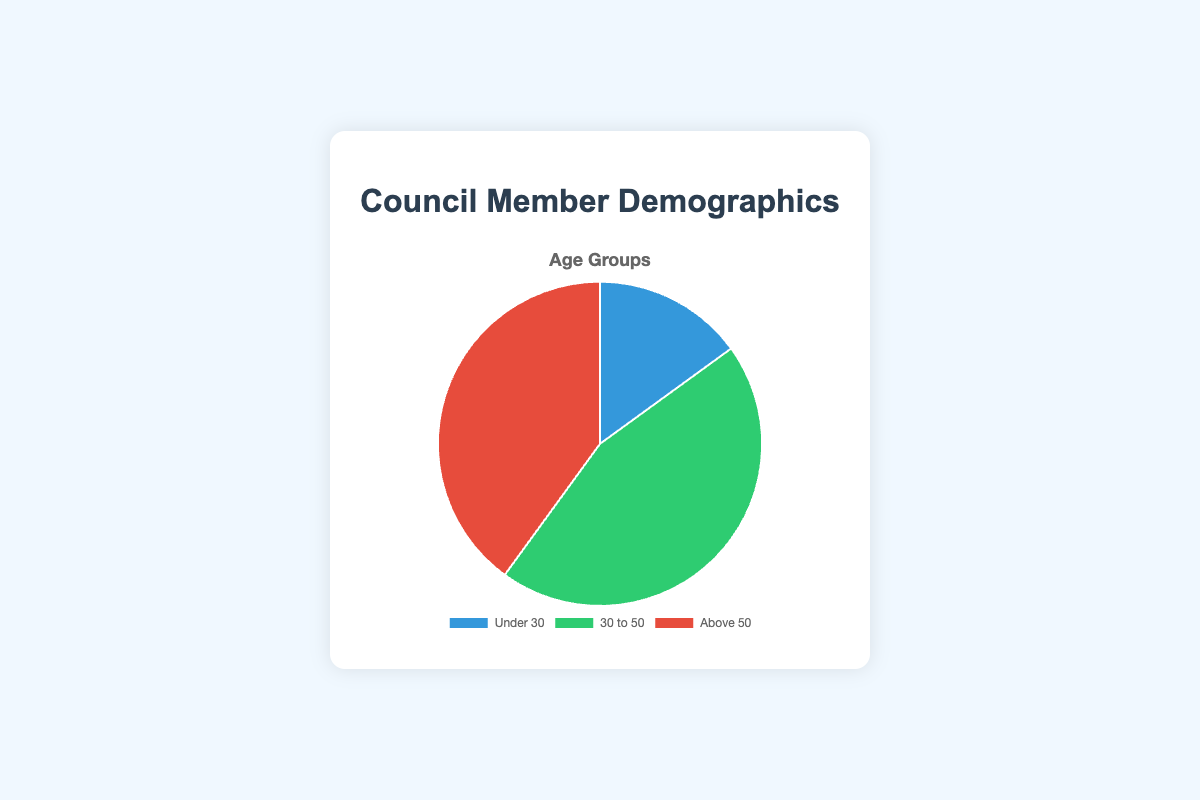What percentage of council members are under 50? To find the percentage of council members under 50, combine the values of the 'Under 30' and '30 to 50' groups, which are 15 and 45 respectively. The sum is 15 + 45 = 60. The total number of council members is 100. Therefore, the percentage is (60/100) * 100 = 60%.
Answer: 60% Which age group has the smallest representation? The pie chart shows the values for 'Under 30' as 15, '30 to 50' as 45, and 'Above 50' as 40. The 'Under 30' group is the smallest.
Answer: Under 30 What is the difference in the number of council members between the '30 to 50' and 'Above 50' age groups? The numbers for the '30 to 50' and 'Above 50' groups are 45 and 40 respectively. The difference is 45 - 40 = 5.
Answer: 5 What fraction of the council members are above 50? The number of council members above 50 is 40. The total number of council members is 100. The fraction is 40/100, which can be simplified to 2/5.
Answer: 2/5 Which age group is represented by the green section of the pie chart? According to the visual attributes of the pie chart, the green section represents the '30 to 50' age group.
Answer: 30 to 50 Would you consider the age distribution balanced? Why or why not? By examining the numbers, 'Under 30' is 15%, '30 to 50' is 45%, and 'Above 50' is 40%. The '30 to 50' group has a significantly higher representation than the other two groups, which suggests the distribution is not balanced.
Answer: No, the distribution is not balanced What would happen if the number of members under 30 increased by 10? Currently, there are 15 council members under 30. Increasing this by 10 would make it 25. The new distribution would be: Under 30 = 25, 30 to 50 = 45, Above 50 = 40. This would slightly increase the representation of the 'Under 30' group but still keep the largest group as '30 to 50'.
Answer: The 'Under 30' group would increase to 25 How many council members are there in total, based on the demographic data provided? The pie chart values are 'Under 30' = 15, '30 to 50' = 45, and 'Above 50' = 40. Adding these together gives the total: 15 + 45 + 40 = 100.
Answer: 100 In terms of visualization, which color represents the oldest age group? According to the pie chart, the 'Above 50' age group is represented by the red section.
Answer: Red 